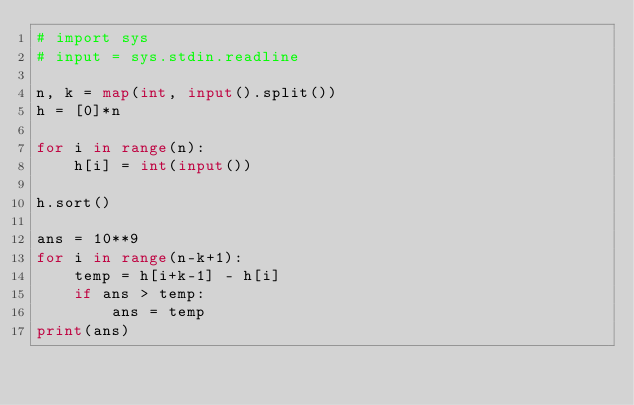<code> <loc_0><loc_0><loc_500><loc_500><_Python_># import sys
# input = sys.stdin.readline

n, k = map(int, input().split())
h = [0]*n

for i in range(n):
    h[i] = int(input())

h.sort()

ans = 10**9
for i in range(n-k+1):
    temp = h[i+k-1] - h[i]
    if ans > temp:
        ans = temp
print(ans)</code> 